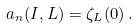Convert formula to latex. <formula><loc_0><loc_0><loc_500><loc_500>a _ { n } ( I , L ) = \zeta _ { L } ( 0 ) \, .</formula> 